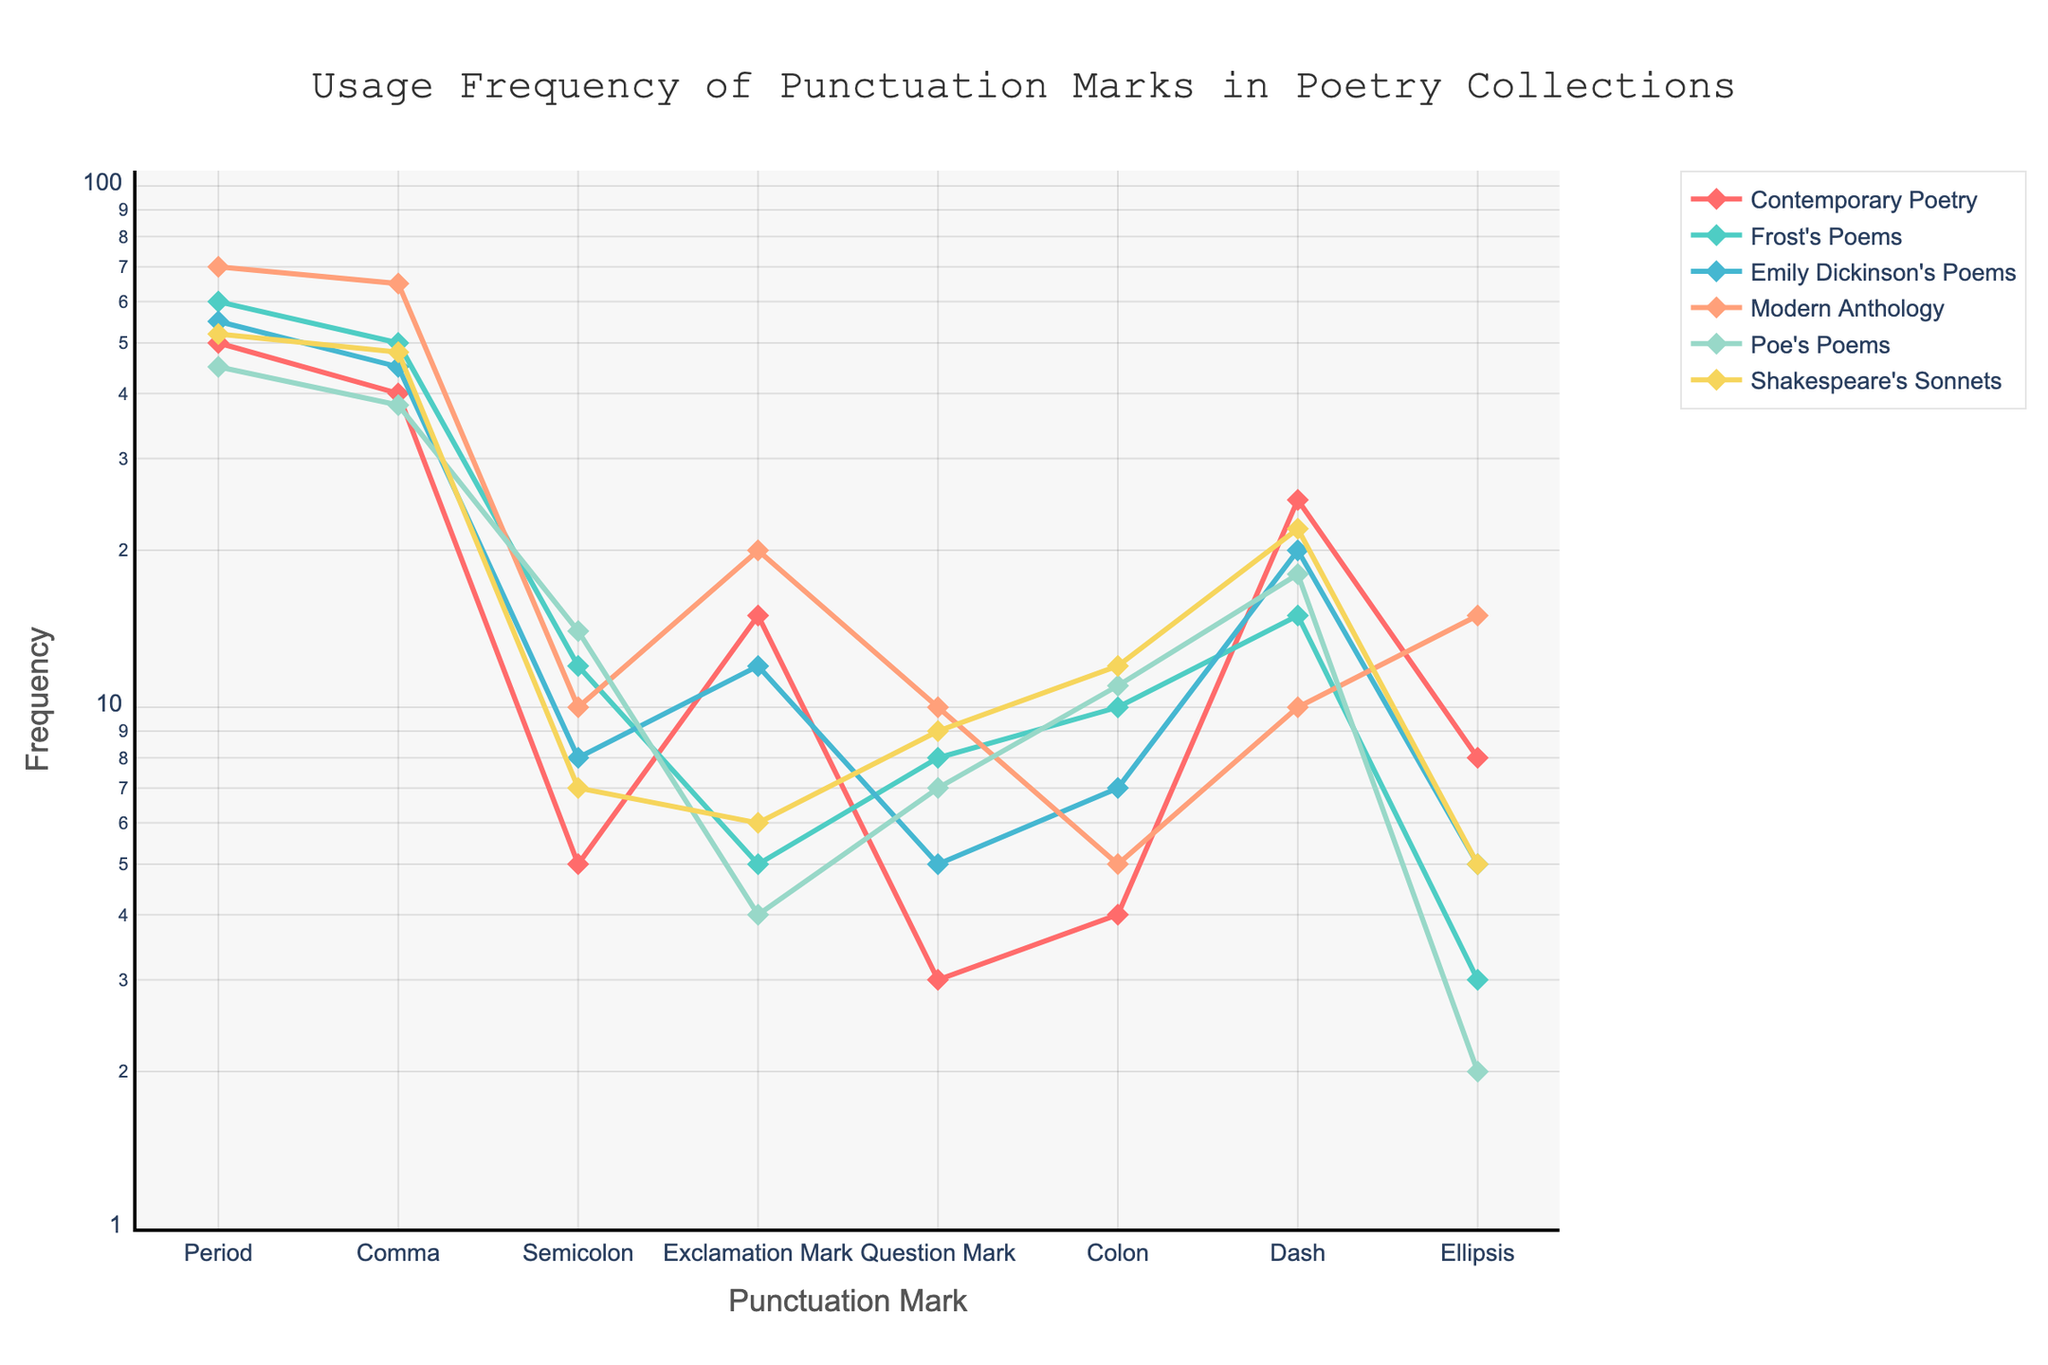What's the title of the figure? The title is displayed at the top of the figure. It reads: "Usage Frequency of Punctuation Marks in Poetry Collections."
Answer: Usage Frequency of Punctuation Marks in Poetry Collections Which collection uses periods the most frequently? On the x-axis, locate the "Period" mark, and observe which line corresponding to each poetry collection reaches the highest y-axis value. The Modern Anthology (the line colored in orange) appears to have the highest value for periods.
Answer: Modern Anthology What is the lowest frequency value for exclamation marks, and which collection does it belong to? The lowest value for exclamation marks can be identified by tracing the line corresponding to the smallest point on the y-axis by looking at the "Exclamation Mark" x-axis tick. The lowest value is 4, which corresponds to Poe's Poems.
Answer: 4, Poe's Poems How does the usage frequency of commas in Shakespeare's Sonnets compare to Emily Dickinson's Poems? First, find the y-axis value for "Comma" under Shakespeare's Sonnets (48). Then, compare it to the y-axis value under Emily Dickinson's Poems (45). Shakespeare's Sonnets use commas slightly more frequently.
Answer: Shakespeare's Sonnets uses commas slightly more frequently than Emily Dickinson's Poems What is the sum of the frequencies for dashes in Frost's Poems and Contemporary Poetry? Find the y-axis value for "Dash" under both Frost's Poems (15) and Contemporary Poetry (25). Sum these values: 15 + 25 = 40.
Answer: 40 By how much does the usage frequency of colons differ between Poe's Poems and Emily Dickinson's Poems? Identify the frequency of colons in both Poe's Poems (11) and Emily Dickinson's Poems (7). Calculate the difference: 11 - 7 = 4.
Answer: 4 Which punctuation mark has the largest frequency range across all collections? Examine each punctuation mark's highest and lowest values across the collections. Calculate the range (highest minus lowest) for each. The period ranges from 70 (Modern Anthology) to 45 (Poe's Poems), resulting in a range of 25. No other punctuation mark shows a larger range.
Answer: Period What pattern can be observed for the usage of semicolons across different collections? Observe the y-axis values for "Semicolon" across the collections. The pattern shows that most collections have relatively low usage with values ranging from 5 to 14, with Frost's Poems having the highest at 14.
Answer: Most collections have low usage, ranging from 5 to 14, with Frost's Poems highest at 14 Which collection shows the steepest increase for the usage of ellipses from 2 to 15 and what does this signify? Follow the ellipses (on the x-axis) tracing the y-values for each collection. The steepest increase is seen in the Modern Anthology, which jumps from 2 to 15. This signifies a high frequency contrast in the usage of ellipses like sudden pauses or unfinished thoughts in Modern Anthology compared to the other collections.
Answer: Modern Anthology, high contrast in usage 